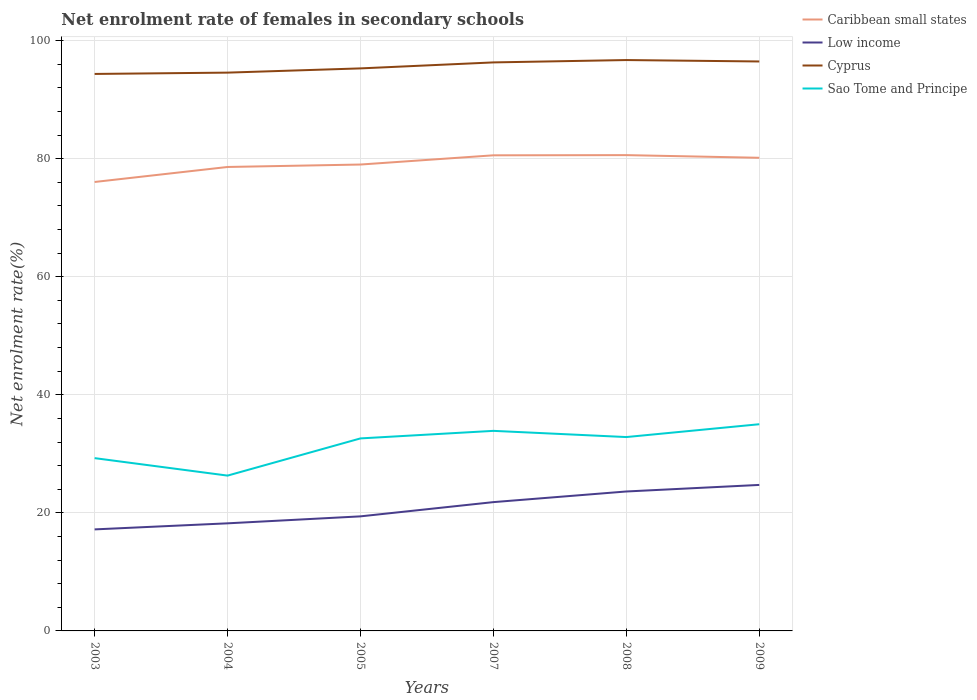How many different coloured lines are there?
Make the answer very short. 4. Across all years, what is the maximum net enrolment rate of females in secondary schools in Sao Tome and Principe?
Offer a very short reply. 26.31. In which year was the net enrolment rate of females in secondary schools in Low income maximum?
Your answer should be very brief. 2003. What is the total net enrolment rate of females in secondary schools in Cyprus in the graph?
Ensure brevity in your answer.  -1.73. What is the difference between the highest and the second highest net enrolment rate of females in secondary schools in Sao Tome and Principe?
Ensure brevity in your answer.  8.7. Is the net enrolment rate of females in secondary schools in Sao Tome and Principe strictly greater than the net enrolment rate of females in secondary schools in Low income over the years?
Give a very brief answer. No. How many lines are there?
Provide a succinct answer. 4. How many years are there in the graph?
Offer a terse response. 6. What is the difference between two consecutive major ticks on the Y-axis?
Give a very brief answer. 20. Does the graph contain any zero values?
Ensure brevity in your answer.  No. Does the graph contain grids?
Provide a short and direct response. Yes. Where does the legend appear in the graph?
Make the answer very short. Top right. What is the title of the graph?
Offer a very short reply. Net enrolment rate of females in secondary schools. What is the label or title of the X-axis?
Provide a succinct answer. Years. What is the label or title of the Y-axis?
Make the answer very short. Net enrolment rate(%). What is the Net enrolment rate(%) in Caribbean small states in 2003?
Ensure brevity in your answer.  76.05. What is the Net enrolment rate(%) in Low income in 2003?
Provide a succinct answer. 17.2. What is the Net enrolment rate(%) of Cyprus in 2003?
Offer a very short reply. 94.35. What is the Net enrolment rate(%) of Sao Tome and Principe in 2003?
Your answer should be compact. 29.27. What is the Net enrolment rate(%) of Caribbean small states in 2004?
Offer a very short reply. 78.59. What is the Net enrolment rate(%) of Low income in 2004?
Provide a succinct answer. 18.23. What is the Net enrolment rate(%) in Cyprus in 2004?
Your response must be concise. 94.57. What is the Net enrolment rate(%) of Sao Tome and Principe in 2004?
Your answer should be compact. 26.31. What is the Net enrolment rate(%) of Caribbean small states in 2005?
Provide a succinct answer. 79. What is the Net enrolment rate(%) in Low income in 2005?
Provide a succinct answer. 19.41. What is the Net enrolment rate(%) in Cyprus in 2005?
Keep it short and to the point. 95.29. What is the Net enrolment rate(%) of Sao Tome and Principe in 2005?
Your response must be concise. 32.61. What is the Net enrolment rate(%) of Caribbean small states in 2007?
Your answer should be very brief. 80.56. What is the Net enrolment rate(%) of Low income in 2007?
Provide a succinct answer. 21.82. What is the Net enrolment rate(%) of Cyprus in 2007?
Ensure brevity in your answer.  96.3. What is the Net enrolment rate(%) of Sao Tome and Principe in 2007?
Provide a succinct answer. 33.89. What is the Net enrolment rate(%) of Caribbean small states in 2008?
Provide a succinct answer. 80.6. What is the Net enrolment rate(%) of Low income in 2008?
Give a very brief answer. 23.62. What is the Net enrolment rate(%) in Cyprus in 2008?
Provide a short and direct response. 96.7. What is the Net enrolment rate(%) in Sao Tome and Principe in 2008?
Your answer should be compact. 32.84. What is the Net enrolment rate(%) in Caribbean small states in 2009?
Your response must be concise. 80.14. What is the Net enrolment rate(%) in Low income in 2009?
Your response must be concise. 24.73. What is the Net enrolment rate(%) of Cyprus in 2009?
Keep it short and to the point. 96.46. What is the Net enrolment rate(%) in Sao Tome and Principe in 2009?
Make the answer very short. 35.01. Across all years, what is the maximum Net enrolment rate(%) of Caribbean small states?
Your response must be concise. 80.6. Across all years, what is the maximum Net enrolment rate(%) in Low income?
Provide a succinct answer. 24.73. Across all years, what is the maximum Net enrolment rate(%) of Cyprus?
Keep it short and to the point. 96.7. Across all years, what is the maximum Net enrolment rate(%) of Sao Tome and Principe?
Provide a short and direct response. 35.01. Across all years, what is the minimum Net enrolment rate(%) of Caribbean small states?
Offer a terse response. 76.05. Across all years, what is the minimum Net enrolment rate(%) of Low income?
Your answer should be very brief. 17.2. Across all years, what is the minimum Net enrolment rate(%) of Cyprus?
Ensure brevity in your answer.  94.35. Across all years, what is the minimum Net enrolment rate(%) in Sao Tome and Principe?
Your response must be concise. 26.31. What is the total Net enrolment rate(%) of Caribbean small states in the graph?
Make the answer very short. 474.94. What is the total Net enrolment rate(%) of Low income in the graph?
Keep it short and to the point. 125. What is the total Net enrolment rate(%) in Cyprus in the graph?
Your answer should be compact. 573.66. What is the total Net enrolment rate(%) in Sao Tome and Principe in the graph?
Provide a succinct answer. 189.93. What is the difference between the Net enrolment rate(%) of Caribbean small states in 2003 and that in 2004?
Ensure brevity in your answer.  -2.54. What is the difference between the Net enrolment rate(%) in Low income in 2003 and that in 2004?
Keep it short and to the point. -1.03. What is the difference between the Net enrolment rate(%) in Cyprus in 2003 and that in 2004?
Keep it short and to the point. -0.22. What is the difference between the Net enrolment rate(%) in Sao Tome and Principe in 2003 and that in 2004?
Offer a very short reply. 2.96. What is the difference between the Net enrolment rate(%) in Caribbean small states in 2003 and that in 2005?
Keep it short and to the point. -2.96. What is the difference between the Net enrolment rate(%) in Low income in 2003 and that in 2005?
Provide a succinct answer. -2.21. What is the difference between the Net enrolment rate(%) in Cyprus in 2003 and that in 2005?
Offer a very short reply. -0.94. What is the difference between the Net enrolment rate(%) of Sao Tome and Principe in 2003 and that in 2005?
Give a very brief answer. -3.34. What is the difference between the Net enrolment rate(%) in Caribbean small states in 2003 and that in 2007?
Make the answer very short. -4.52. What is the difference between the Net enrolment rate(%) of Low income in 2003 and that in 2007?
Offer a terse response. -4.62. What is the difference between the Net enrolment rate(%) in Cyprus in 2003 and that in 2007?
Give a very brief answer. -1.95. What is the difference between the Net enrolment rate(%) of Sao Tome and Principe in 2003 and that in 2007?
Provide a succinct answer. -4.62. What is the difference between the Net enrolment rate(%) of Caribbean small states in 2003 and that in 2008?
Give a very brief answer. -4.55. What is the difference between the Net enrolment rate(%) in Low income in 2003 and that in 2008?
Offer a very short reply. -6.42. What is the difference between the Net enrolment rate(%) in Cyprus in 2003 and that in 2008?
Your answer should be very brief. -2.35. What is the difference between the Net enrolment rate(%) of Sao Tome and Principe in 2003 and that in 2008?
Keep it short and to the point. -3.57. What is the difference between the Net enrolment rate(%) of Caribbean small states in 2003 and that in 2009?
Ensure brevity in your answer.  -4.1. What is the difference between the Net enrolment rate(%) in Low income in 2003 and that in 2009?
Ensure brevity in your answer.  -7.53. What is the difference between the Net enrolment rate(%) of Cyprus in 2003 and that in 2009?
Your answer should be compact. -2.11. What is the difference between the Net enrolment rate(%) of Sao Tome and Principe in 2003 and that in 2009?
Make the answer very short. -5.74. What is the difference between the Net enrolment rate(%) of Caribbean small states in 2004 and that in 2005?
Provide a short and direct response. -0.41. What is the difference between the Net enrolment rate(%) in Low income in 2004 and that in 2005?
Keep it short and to the point. -1.18. What is the difference between the Net enrolment rate(%) in Cyprus in 2004 and that in 2005?
Give a very brief answer. -0.72. What is the difference between the Net enrolment rate(%) in Sao Tome and Principe in 2004 and that in 2005?
Make the answer very short. -6.3. What is the difference between the Net enrolment rate(%) of Caribbean small states in 2004 and that in 2007?
Offer a terse response. -1.98. What is the difference between the Net enrolment rate(%) in Low income in 2004 and that in 2007?
Ensure brevity in your answer.  -3.59. What is the difference between the Net enrolment rate(%) in Cyprus in 2004 and that in 2007?
Provide a succinct answer. -1.73. What is the difference between the Net enrolment rate(%) in Sao Tome and Principe in 2004 and that in 2007?
Provide a short and direct response. -7.58. What is the difference between the Net enrolment rate(%) in Caribbean small states in 2004 and that in 2008?
Your response must be concise. -2.01. What is the difference between the Net enrolment rate(%) of Low income in 2004 and that in 2008?
Offer a very short reply. -5.39. What is the difference between the Net enrolment rate(%) in Cyprus in 2004 and that in 2008?
Your answer should be very brief. -2.13. What is the difference between the Net enrolment rate(%) in Sao Tome and Principe in 2004 and that in 2008?
Your response must be concise. -6.53. What is the difference between the Net enrolment rate(%) in Caribbean small states in 2004 and that in 2009?
Make the answer very short. -1.56. What is the difference between the Net enrolment rate(%) in Low income in 2004 and that in 2009?
Provide a succinct answer. -6.51. What is the difference between the Net enrolment rate(%) in Cyprus in 2004 and that in 2009?
Offer a very short reply. -1.89. What is the difference between the Net enrolment rate(%) of Sao Tome and Principe in 2004 and that in 2009?
Your answer should be very brief. -8.7. What is the difference between the Net enrolment rate(%) in Caribbean small states in 2005 and that in 2007?
Offer a terse response. -1.56. What is the difference between the Net enrolment rate(%) in Low income in 2005 and that in 2007?
Make the answer very short. -2.41. What is the difference between the Net enrolment rate(%) of Cyprus in 2005 and that in 2007?
Ensure brevity in your answer.  -1.01. What is the difference between the Net enrolment rate(%) of Sao Tome and Principe in 2005 and that in 2007?
Make the answer very short. -1.28. What is the difference between the Net enrolment rate(%) of Caribbean small states in 2005 and that in 2008?
Keep it short and to the point. -1.59. What is the difference between the Net enrolment rate(%) in Low income in 2005 and that in 2008?
Make the answer very short. -4.21. What is the difference between the Net enrolment rate(%) in Cyprus in 2005 and that in 2008?
Offer a very short reply. -1.41. What is the difference between the Net enrolment rate(%) in Sao Tome and Principe in 2005 and that in 2008?
Your answer should be compact. -0.23. What is the difference between the Net enrolment rate(%) of Caribbean small states in 2005 and that in 2009?
Offer a terse response. -1.14. What is the difference between the Net enrolment rate(%) of Low income in 2005 and that in 2009?
Ensure brevity in your answer.  -5.32. What is the difference between the Net enrolment rate(%) of Cyprus in 2005 and that in 2009?
Give a very brief answer. -1.17. What is the difference between the Net enrolment rate(%) of Sao Tome and Principe in 2005 and that in 2009?
Offer a terse response. -2.4. What is the difference between the Net enrolment rate(%) in Caribbean small states in 2007 and that in 2008?
Provide a short and direct response. -0.03. What is the difference between the Net enrolment rate(%) in Low income in 2007 and that in 2008?
Ensure brevity in your answer.  -1.8. What is the difference between the Net enrolment rate(%) in Cyprus in 2007 and that in 2008?
Offer a terse response. -0.4. What is the difference between the Net enrolment rate(%) of Sao Tome and Principe in 2007 and that in 2008?
Provide a short and direct response. 1.05. What is the difference between the Net enrolment rate(%) of Caribbean small states in 2007 and that in 2009?
Give a very brief answer. 0.42. What is the difference between the Net enrolment rate(%) in Low income in 2007 and that in 2009?
Offer a very short reply. -2.91. What is the difference between the Net enrolment rate(%) in Cyprus in 2007 and that in 2009?
Provide a short and direct response. -0.16. What is the difference between the Net enrolment rate(%) of Sao Tome and Principe in 2007 and that in 2009?
Your response must be concise. -1.12. What is the difference between the Net enrolment rate(%) in Caribbean small states in 2008 and that in 2009?
Provide a succinct answer. 0.45. What is the difference between the Net enrolment rate(%) of Low income in 2008 and that in 2009?
Keep it short and to the point. -1.11. What is the difference between the Net enrolment rate(%) of Cyprus in 2008 and that in 2009?
Offer a very short reply. 0.24. What is the difference between the Net enrolment rate(%) of Sao Tome and Principe in 2008 and that in 2009?
Your response must be concise. -2.17. What is the difference between the Net enrolment rate(%) in Caribbean small states in 2003 and the Net enrolment rate(%) in Low income in 2004?
Keep it short and to the point. 57.82. What is the difference between the Net enrolment rate(%) in Caribbean small states in 2003 and the Net enrolment rate(%) in Cyprus in 2004?
Your response must be concise. -18.52. What is the difference between the Net enrolment rate(%) of Caribbean small states in 2003 and the Net enrolment rate(%) of Sao Tome and Principe in 2004?
Your answer should be compact. 49.74. What is the difference between the Net enrolment rate(%) in Low income in 2003 and the Net enrolment rate(%) in Cyprus in 2004?
Give a very brief answer. -77.37. What is the difference between the Net enrolment rate(%) of Low income in 2003 and the Net enrolment rate(%) of Sao Tome and Principe in 2004?
Offer a very short reply. -9.11. What is the difference between the Net enrolment rate(%) in Cyprus in 2003 and the Net enrolment rate(%) in Sao Tome and Principe in 2004?
Your answer should be compact. 68.04. What is the difference between the Net enrolment rate(%) of Caribbean small states in 2003 and the Net enrolment rate(%) of Low income in 2005?
Give a very brief answer. 56.64. What is the difference between the Net enrolment rate(%) in Caribbean small states in 2003 and the Net enrolment rate(%) in Cyprus in 2005?
Offer a terse response. -19.24. What is the difference between the Net enrolment rate(%) of Caribbean small states in 2003 and the Net enrolment rate(%) of Sao Tome and Principe in 2005?
Provide a short and direct response. 43.44. What is the difference between the Net enrolment rate(%) in Low income in 2003 and the Net enrolment rate(%) in Cyprus in 2005?
Your answer should be very brief. -78.09. What is the difference between the Net enrolment rate(%) in Low income in 2003 and the Net enrolment rate(%) in Sao Tome and Principe in 2005?
Ensure brevity in your answer.  -15.41. What is the difference between the Net enrolment rate(%) in Cyprus in 2003 and the Net enrolment rate(%) in Sao Tome and Principe in 2005?
Keep it short and to the point. 61.74. What is the difference between the Net enrolment rate(%) in Caribbean small states in 2003 and the Net enrolment rate(%) in Low income in 2007?
Keep it short and to the point. 54.23. What is the difference between the Net enrolment rate(%) of Caribbean small states in 2003 and the Net enrolment rate(%) of Cyprus in 2007?
Offer a terse response. -20.25. What is the difference between the Net enrolment rate(%) in Caribbean small states in 2003 and the Net enrolment rate(%) in Sao Tome and Principe in 2007?
Your response must be concise. 42.16. What is the difference between the Net enrolment rate(%) of Low income in 2003 and the Net enrolment rate(%) of Cyprus in 2007?
Your response must be concise. -79.1. What is the difference between the Net enrolment rate(%) in Low income in 2003 and the Net enrolment rate(%) in Sao Tome and Principe in 2007?
Your response must be concise. -16.69. What is the difference between the Net enrolment rate(%) in Cyprus in 2003 and the Net enrolment rate(%) in Sao Tome and Principe in 2007?
Ensure brevity in your answer.  60.46. What is the difference between the Net enrolment rate(%) of Caribbean small states in 2003 and the Net enrolment rate(%) of Low income in 2008?
Your answer should be very brief. 52.43. What is the difference between the Net enrolment rate(%) in Caribbean small states in 2003 and the Net enrolment rate(%) in Cyprus in 2008?
Your answer should be very brief. -20.65. What is the difference between the Net enrolment rate(%) in Caribbean small states in 2003 and the Net enrolment rate(%) in Sao Tome and Principe in 2008?
Ensure brevity in your answer.  43.21. What is the difference between the Net enrolment rate(%) of Low income in 2003 and the Net enrolment rate(%) of Cyprus in 2008?
Make the answer very short. -79.5. What is the difference between the Net enrolment rate(%) in Low income in 2003 and the Net enrolment rate(%) in Sao Tome and Principe in 2008?
Offer a terse response. -15.64. What is the difference between the Net enrolment rate(%) in Cyprus in 2003 and the Net enrolment rate(%) in Sao Tome and Principe in 2008?
Keep it short and to the point. 61.51. What is the difference between the Net enrolment rate(%) of Caribbean small states in 2003 and the Net enrolment rate(%) of Low income in 2009?
Your answer should be compact. 51.32. What is the difference between the Net enrolment rate(%) in Caribbean small states in 2003 and the Net enrolment rate(%) in Cyprus in 2009?
Ensure brevity in your answer.  -20.41. What is the difference between the Net enrolment rate(%) in Caribbean small states in 2003 and the Net enrolment rate(%) in Sao Tome and Principe in 2009?
Offer a very short reply. 41.04. What is the difference between the Net enrolment rate(%) in Low income in 2003 and the Net enrolment rate(%) in Cyprus in 2009?
Your response must be concise. -79.26. What is the difference between the Net enrolment rate(%) of Low income in 2003 and the Net enrolment rate(%) of Sao Tome and Principe in 2009?
Keep it short and to the point. -17.81. What is the difference between the Net enrolment rate(%) of Cyprus in 2003 and the Net enrolment rate(%) of Sao Tome and Principe in 2009?
Your response must be concise. 59.34. What is the difference between the Net enrolment rate(%) of Caribbean small states in 2004 and the Net enrolment rate(%) of Low income in 2005?
Give a very brief answer. 59.18. What is the difference between the Net enrolment rate(%) of Caribbean small states in 2004 and the Net enrolment rate(%) of Cyprus in 2005?
Offer a terse response. -16.7. What is the difference between the Net enrolment rate(%) of Caribbean small states in 2004 and the Net enrolment rate(%) of Sao Tome and Principe in 2005?
Keep it short and to the point. 45.98. What is the difference between the Net enrolment rate(%) in Low income in 2004 and the Net enrolment rate(%) in Cyprus in 2005?
Provide a succinct answer. -77.06. What is the difference between the Net enrolment rate(%) of Low income in 2004 and the Net enrolment rate(%) of Sao Tome and Principe in 2005?
Keep it short and to the point. -14.39. What is the difference between the Net enrolment rate(%) of Cyprus in 2004 and the Net enrolment rate(%) of Sao Tome and Principe in 2005?
Your answer should be very brief. 61.96. What is the difference between the Net enrolment rate(%) in Caribbean small states in 2004 and the Net enrolment rate(%) in Low income in 2007?
Your answer should be compact. 56.77. What is the difference between the Net enrolment rate(%) in Caribbean small states in 2004 and the Net enrolment rate(%) in Cyprus in 2007?
Give a very brief answer. -17.71. What is the difference between the Net enrolment rate(%) of Caribbean small states in 2004 and the Net enrolment rate(%) of Sao Tome and Principe in 2007?
Your answer should be compact. 44.7. What is the difference between the Net enrolment rate(%) of Low income in 2004 and the Net enrolment rate(%) of Cyprus in 2007?
Ensure brevity in your answer.  -78.08. What is the difference between the Net enrolment rate(%) in Low income in 2004 and the Net enrolment rate(%) in Sao Tome and Principe in 2007?
Offer a very short reply. -15.66. What is the difference between the Net enrolment rate(%) in Cyprus in 2004 and the Net enrolment rate(%) in Sao Tome and Principe in 2007?
Give a very brief answer. 60.68. What is the difference between the Net enrolment rate(%) in Caribbean small states in 2004 and the Net enrolment rate(%) in Low income in 2008?
Provide a succinct answer. 54.97. What is the difference between the Net enrolment rate(%) of Caribbean small states in 2004 and the Net enrolment rate(%) of Cyprus in 2008?
Ensure brevity in your answer.  -18.11. What is the difference between the Net enrolment rate(%) in Caribbean small states in 2004 and the Net enrolment rate(%) in Sao Tome and Principe in 2008?
Give a very brief answer. 45.75. What is the difference between the Net enrolment rate(%) in Low income in 2004 and the Net enrolment rate(%) in Cyprus in 2008?
Your answer should be very brief. -78.48. What is the difference between the Net enrolment rate(%) of Low income in 2004 and the Net enrolment rate(%) of Sao Tome and Principe in 2008?
Provide a succinct answer. -14.61. What is the difference between the Net enrolment rate(%) of Cyprus in 2004 and the Net enrolment rate(%) of Sao Tome and Principe in 2008?
Give a very brief answer. 61.73. What is the difference between the Net enrolment rate(%) in Caribbean small states in 2004 and the Net enrolment rate(%) in Low income in 2009?
Keep it short and to the point. 53.86. What is the difference between the Net enrolment rate(%) in Caribbean small states in 2004 and the Net enrolment rate(%) in Cyprus in 2009?
Your response must be concise. -17.87. What is the difference between the Net enrolment rate(%) of Caribbean small states in 2004 and the Net enrolment rate(%) of Sao Tome and Principe in 2009?
Offer a terse response. 43.58. What is the difference between the Net enrolment rate(%) in Low income in 2004 and the Net enrolment rate(%) in Cyprus in 2009?
Provide a succinct answer. -78.23. What is the difference between the Net enrolment rate(%) of Low income in 2004 and the Net enrolment rate(%) of Sao Tome and Principe in 2009?
Your answer should be very brief. -16.79. What is the difference between the Net enrolment rate(%) in Cyprus in 2004 and the Net enrolment rate(%) in Sao Tome and Principe in 2009?
Offer a very short reply. 59.56. What is the difference between the Net enrolment rate(%) in Caribbean small states in 2005 and the Net enrolment rate(%) in Low income in 2007?
Your answer should be compact. 57.18. What is the difference between the Net enrolment rate(%) in Caribbean small states in 2005 and the Net enrolment rate(%) in Cyprus in 2007?
Ensure brevity in your answer.  -17.3. What is the difference between the Net enrolment rate(%) of Caribbean small states in 2005 and the Net enrolment rate(%) of Sao Tome and Principe in 2007?
Your answer should be very brief. 45.11. What is the difference between the Net enrolment rate(%) in Low income in 2005 and the Net enrolment rate(%) in Cyprus in 2007?
Provide a short and direct response. -76.89. What is the difference between the Net enrolment rate(%) in Low income in 2005 and the Net enrolment rate(%) in Sao Tome and Principe in 2007?
Make the answer very short. -14.48. What is the difference between the Net enrolment rate(%) in Cyprus in 2005 and the Net enrolment rate(%) in Sao Tome and Principe in 2007?
Your answer should be compact. 61.4. What is the difference between the Net enrolment rate(%) in Caribbean small states in 2005 and the Net enrolment rate(%) in Low income in 2008?
Your answer should be compact. 55.38. What is the difference between the Net enrolment rate(%) of Caribbean small states in 2005 and the Net enrolment rate(%) of Cyprus in 2008?
Your answer should be very brief. -17.7. What is the difference between the Net enrolment rate(%) of Caribbean small states in 2005 and the Net enrolment rate(%) of Sao Tome and Principe in 2008?
Give a very brief answer. 46.16. What is the difference between the Net enrolment rate(%) of Low income in 2005 and the Net enrolment rate(%) of Cyprus in 2008?
Provide a succinct answer. -77.29. What is the difference between the Net enrolment rate(%) in Low income in 2005 and the Net enrolment rate(%) in Sao Tome and Principe in 2008?
Offer a very short reply. -13.43. What is the difference between the Net enrolment rate(%) in Cyprus in 2005 and the Net enrolment rate(%) in Sao Tome and Principe in 2008?
Give a very brief answer. 62.45. What is the difference between the Net enrolment rate(%) of Caribbean small states in 2005 and the Net enrolment rate(%) of Low income in 2009?
Make the answer very short. 54.27. What is the difference between the Net enrolment rate(%) in Caribbean small states in 2005 and the Net enrolment rate(%) in Cyprus in 2009?
Your answer should be very brief. -17.46. What is the difference between the Net enrolment rate(%) in Caribbean small states in 2005 and the Net enrolment rate(%) in Sao Tome and Principe in 2009?
Ensure brevity in your answer.  43.99. What is the difference between the Net enrolment rate(%) in Low income in 2005 and the Net enrolment rate(%) in Cyprus in 2009?
Your response must be concise. -77.05. What is the difference between the Net enrolment rate(%) of Low income in 2005 and the Net enrolment rate(%) of Sao Tome and Principe in 2009?
Give a very brief answer. -15.6. What is the difference between the Net enrolment rate(%) of Cyprus in 2005 and the Net enrolment rate(%) of Sao Tome and Principe in 2009?
Your response must be concise. 60.28. What is the difference between the Net enrolment rate(%) in Caribbean small states in 2007 and the Net enrolment rate(%) in Low income in 2008?
Offer a very short reply. 56.94. What is the difference between the Net enrolment rate(%) of Caribbean small states in 2007 and the Net enrolment rate(%) of Cyprus in 2008?
Ensure brevity in your answer.  -16.14. What is the difference between the Net enrolment rate(%) of Caribbean small states in 2007 and the Net enrolment rate(%) of Sao Tome and Principe in 2008?
Your response must be concise. 47.73. What is the difference between the Net enrolment rate(%) in Low income in 2007 and the Net enrolment rate(%) in Cyprus in 2008?
Make the answer very short. -74.88. What is the difference between the Net enrolment rate(%) in Low income in 2007 and the Net enrolment rate(%) in Sao Tome and Principe in 2008?
Ensure brevity in your answer.  -11.02. What is the difference between the Net enrolment rate(%) in Cyprus in 2007 and the Net enrolment rate(%) in Sao Tome and Principe in 2008?
Provide a succinct answer. 63.46. What is the difference between the Net enrolment rate(%) of Caribbean small states in 2007 and the Net enrolment rate(%) of Low income in 2009?
Your answer should be compact. 55.83. What is the difference between the Net enrolment rate(%) of Caribbean small states in 2007 and the Net enrolment rate(%) of Cyprus in 2009?
Provide a short and direct response. -15.9. What is the difference between the Net enrolment rate(%) in Caribbean small states in 2007 and the Net enrolment rate(%) in Sao Tome and Principe in 2009?
Offer a very short reply. 45.55. What is the difference between the Net enrolment rate(%) in Low income in 2007 and the Net enrolment rate(%) in Cyprus in 2009?
Give a very brief answer. -74.64. What is the difference between the Net enrolment rate(%) in Low income in 2007 and the Net enrolment rate(%) in Sao Tome and Principe in 2009?
Provide a short and direct response. -13.19. What is the difference between the Net enrolment rate(%) in Cyprus in 2007 and the Net enrolment rate(%) in Sao Tome and Principe in 2009?
Your answer should be very brief. 61.29. What is the difference between the Net enrolment rate(%) of Caribbean small states in 2008 and the Net enrolment rate(%) of Low income in 2009?
Offer a terse response. 55.86. What is the difference between the Net enrolment rate(%) of Caribbean small states in 2008 and the Net enrolment rate(%) of Cyprus in 2009?
Provide a succinct answer. -15.86. What is the difference between the Net enrolment rate(%) in Caribbean small states in 2008 and the Net enrolment rate(%) in Sao Tome and Principe in 2009?
Make the answer very short. 45.58. What is the difference between the Net enrolment rate(%) of Low income in 2008 and the Net enrolment rate(%) of Cyprus in 2009?
Provide a succinct answer. -72.84. What is the difference between the Net enrolment rate(%) in Low income in 2008 and the Net enrolment rate(%) in Sao Tome and Principe in 2009?
Provide a short and direct response. -11.39. What is the difference between the Net enrolment rate(%) in Cyprus in 2008 and the Net enrolment rate(%) in Sao Tome and Principe in 2009?
Provide a short and direct response. 61.69. What is the average Net enrolment rate(%) in Caribbean small states per year?
Make the answer very short. 79.16. What is the average Net enrolment rate(%) in Low income per year?
Keep it short and to the point. 20.83. What is the average Net enrolment rate(%) in Cyprus per year?
Give a very brief answer. 95.61. What is the average Net enrolment rate(%) of Sao Tome and Principe per year?
Your answer should be compact. 31.65. In the year 2003, what is the difference between the Net enrolment rate(%) of Caribbean small states and Net enrolment rate(%) of Low income?
Offer a very short reply. 58.85. In the year 2003, what is the difference between the Net enrolment rate(%) in Caribbean small states and Net enrolment rate(%) in Cyprus?
Provide a short and direct response. -18.3. In the year 2003, what is the difference between the Net enrolment rate(%) of Caribbean small states and Net enrolment rate(%) of Sao Tome and Principe?
Give a very brief answer. 46.78. In the year 2003, what is the difference between the Net enrolment rate(%) of Low income and Net enrolment rate(%) of Cyprus?
Keep it short and to the point. -77.15. In the year 2003, what is the difference between the Net enrolment rate(%) of Low income and Net enrolment rate(%) of Sao Tome and Principe?
Your answer should be compact. -12.07. In the year 2003, what is the difference between the Net enrolment rate(%) of Cyprus and Net enrolment rate(%) of Sao Tome and Principe?
Make the answer very short. 65.08. In the year 2004, what is the difference between the Net enrolment rate(%) of Caribbean small states and Net enrolment rate(%) of Low income?
Give a very brief answer. 60.36. In the year 2004, what is the difference between the Net enrolment rate(%) of Caribbean small states and Net enrolment rate(%) of Cyprus?
Provide a succinct answer. -15.98. In the year 2004, what is the difference between the Net enrolment rate(%) in Caribbean small states and Net enrolment rate(%) in Sao Tome and Principe?
Offer a very short reply. 52.28. In the year 2004, what is the difference between the Net enrolment rate(%) of Low income and Net enrolment rate(%) of Cyprus?
Your answer should be compact. -76.34. In the year 2004, what is the difference between the Net enrolment rate(%) of Low income and Net enrolment rate(%) of Sao Tome and Principe?
Offer a very short reply. -8.08. In the year 2004, what is the difference between the Net enrolment rate(%) of Cyprus and Net enrolment rate(%) of Sao Tome and Principe?
Offer a very short reply. 68.26. In the year 2005, what is the difference between the Net enrolment rate(%) in Caribbean small states and Net enrolment rate(%) in Low income?
Ensure brevity in your answer.  59.6. In the year 2005, what is the difference between the Net enrolment rate(%) in Caribbean small states and Net enrolment rate(%) in Cyprus?
Keep it short and to the point. -16.29. In the year 2005, what is the difference between the Net enrolment rate(%) of Caribbean small states and Net enrolment rate(%) of Sao Tome and Principe?
Give a very brief answer. 46.39. In the year 2005, what is the difference between the Net enrolment rate(%) in Low income and Net enrolment rate(%) in Cyprus?
Give a very brief answer. -75.88. In the year 2005, what is the difference between the Net enrolment rate(%) of Low income and Net enrolment rate(%) of Sao Tome and Principe?
Provide a succinct answer. -13.2. In the year 2005, what is the difference between the Net enrolment rate(%) of Cyprus and Net enrolment rate(%) of Sao Tome and Principe?
Your answer should be very brief. 62.68. In the year 2007, what is the difference between the Net enrolment rate(%) in Caribbean small states and Net enrolment rate(%) in Low income?
Make the answer very short. 58.75. In the year 2007, what is the difference between the Net enrolment rate(%) in Caribbean small states and Net enrolment rate(%) in Cyprus?
Offer a terse response. -15.74. In the year 2007, what is the difference between the Net enrolment rate(%) in Caribbean small states and Net enrolment rate(%) in Sao Tome and Principe?
Your answer should be very brief. 46.68. In the year 2007, what is the difference between the Net enrolment rate(%) of Low income and Net enrolment rate(%) of Cyprus?
Offer a very short reply. -74.48. In the year 2007, what is the difference between the Net enrolment rate(%) in Low income and Net enrolment rate(%) in Sao Tome and Principe?
Your response must be concise. -12.07. In the year 2007, what is the difference between the Net enrolment rate(%) in Cyprus and Net enrolment rate(%) in Sao Tome and Principe?
Give a very brief answer. 62.41. In the year 2008, what is the difference between the Net enrolment rate(%) in Caribbean small states and Net enrolment rate(%) in Low income?
Your answer should be compact. 56.98. In the year 2008, what is the difference between the Net enrolment rate(%) in Caribbean small states and Net enrolment rate(%) in Cyprus?
Provide a succinct answer. -16.11. In the year 2008, what is the difference between the Net enrolment rate(%) of Caribbean small states and Net enrolment rate(%) of Sao Tome and Principe?
Give a very brief answer. 47.76. In the year 2008, what is the difference between the Net enrolment rate(%) of Low income and Net enrolment rate(%) of Cyprus?
Offer a very short reply. -73.08. In the year 2008, what is the difference between the Net enrolment rate(%) of Low income and Net enrolment rate(%) of Sao Tome and Principe?
Provide a succinct answer. -9.22. In the year 2008, what is the difference between the Net enrolment rate(%) in Cyprus and Net enrolment rate(%) in Sao Tome and Principe?
Make the answer very short. 63.86. In the year 2009, what is the difference between the Net enrolment rate(%) of Caribbean small states and Net enrolment rate(%) of Low income?
Keep it short and to the point. 55.41. In the year 2009, what is the difference between the Net enrolment rate(%) of Caribbean small states and Net enrolment rate(%) of Cyprus?
Keep it short and to the point. -16.32. In the year 2009, what is the difference between the Net enrolment rate(%) of Caribbean small states and Net enrolment rate(%) of Sao Tome and Principe?
Offer a terse response. 45.13. In the year 2009, what is the difference between the Net enrolment rate(%) in Low income and Net enrolment rate(%) in Cyprus?
Offer a very short reply. -71.73. In the year 2009, what is the difference between the Net enrolment rate(%) of Low income and Net enrolment rate(%) of Sao Tome and Principe?
Offer a very short reply. -10.28. In the year 2009, what is the difference between the Net enrolment rate(%) of Cyprus and Net enrolment rate(%) of Sao Tome and Principe?
Your response must be concise. 61.45. What is the ratio of the Net enrolment rate(%) in Low income in 2003 to that in 2004?
Your answer should be very brief. 0.94. What is the ratio of the Net enrolment rate(%) in Sao Tome and Principe in 2003 to that in 2004?
Keep it short and to the point. 1.11. What is the ratio of the Net enrolment rate(%) in Caribbean small states in 2003 to that in 2005?
Your answer should be compact. 0.96. What is the ratio of the Net enrolment rate(%) in Low income in 2003 to that in 2005?
Give a very brief answer. 0.89. What is the ratio of the Net enrolment rate(%) in Cyprus in 2003 to that in 2005?
Your answer should be very brief. 0.99. What is the ratio of the Net enrolment rate(%) of Sao Tome and Principe in 2003 to that in 2005?
Your answer should be compact. 0.9. What is the ratio of the Net enrolment rate(%) in Caribbean small states in 2003 to that in 2007?
Make the answer very short. 0.94. What is the ratio of the Net enrolment rate(%) of Low income in 2003 to that in 2007?
Your answer should be very brief. 0.79. What is the ratio of the Net enrolment rate(%) of Cyprus in 2003 to that in 2007?
Provide a short and direct response. 0.98. What is the ratio of the Net enrolment rate(%) in Sao Tome and Principe in 2003 to that in 2007?
Your answer should be compact. 0.86. What is the ratio of the Net enrolment rate(%) in Caribbean small states in 2003 to that in 2008?
Keep it short and to the point. 0.94. What is the ratio of the Net enrolment rate(%) of Low income in 2003 to that in 2008?
Your answer should be compact. 0.73. What is the ratio of the Net enrolment rate(%) in Cyprus in 2003 to that in 2008?
Ensure brevity in your answer.  0.98. What is the ratio of the Net enrolment rate(%) in Sao Tome and Principe in 2003 to that in 2008?
Your answer should be very brief. 0.89. What is the ratio of the Net enrolment rate(%) of Caribbean small states in 2003 to that in 2009?
Your answer should be very brief. 0.95. What is the ratio of the Net enrolment rate(%) in Low income in 2003 to that in 2009?
Your answer should be very brief. 0.7. What is the ratio of the Net enrolment rate(%) in Cyprus in 2003 to that in 2009?
Make the answer very short. 0.98. What is the ratio of the Net enrolment rate(%) in Sao Tome and Principe in 2003 to that in 2009?
Ensure brevity in your answer.  0.84. What is the ratio of the Net enrolment rate(%) of Low income in 2004 to that in 2005?
Provide a short and direct response. 0.94. What is the ratio of the Net enrolment rate(%) in Sao Tome and Principe in 2004 to that in 2005?
Give a very brief answer. 0.81. What is the ratio of the Net enrolment rate(%) in Caribbean small states in 2004 to that in 2007?
Ensure brevity in your answer.  0.98. What is the ratio of the Net enrolment rate(%) in Low income in 2004 to that in 2007?
Ensure brevity in your answer.  0.84. What is the ratio of the Net enrolment rate(%) in Sao Tome and Principe in 2004 to that in 2007?
Provide a succinct answer. 0.78. What is the ratio of the Net enrolment rate(%) in Caribbean small states in 2004 to that in 2008?
Your answer should be very brief. 0.98. What is the ratio of the Net enrolment rate(%) in Low income in 2004 to that in 2008?
Ensure brevity in your answer.  0.77. What is the ratio of the Net enrolment rate(%) in Sao Tome and Principe in 2004 to that in 2008?
Ensure brevity in your answer.  0.8. What is the ratio of the Net enrolment rate(%) in Caribbean small states in 2004 to that in 2009?
Offer a very short reply. 0.98. What is the ratio of the Net enrolment rate(%) of Low income in 2004 to that in 2009?
Provide a succinct answer. 0.74. What is the ratio of the Net enrolment rate(%) of Cyprus in 2004 to that in 2009?
Keep it short and to the point. 0.98. What is the ratio of the Net enrolment rate(%) in Sao Tome and Principe in 2004 to that in 2009?
Give a very brief answer. 0.75. What is the ratio of the Net enrolment rate(%) in Caribbean small states in 2005 to that in 2007?
Give a very brief answer. 0.98. What is the ratio of the Net enrolment rate(%) of Low income in 2005 to that in 2007?
Offer a very short reply. 0.89. What is the ratio of the Net enrolment rate(%) in Cyprus in 2005 to that in 2007?
Your answer should be very brief. 0.99. What is the ratio of the Net enrolment rate(%) of Sao Tome and Principe in 2005 to that in 2007?
Ensure brevity in your answer.  0.96. What is the ratio of the Net enrolment rate(%) in Caribbean small states in 2005 to that in 2008?
Provide a succinct answer. 0.98. What is the ratio of the Net enrolment rate(%) of Low income in 2005 to that in 2008?
Provide a short and direct response. 0.82. What is the ratio of the Net enrolment rate(%) of Cyprus in 2005 to that in 2008?
Your answer should be compact. 0.99. What is the ratio of the Net enrolment rate(%) in Caribbean small states in 2005 to that in 2009?
Your response must be concise. 0.99. What is the ratio of the Net enrolment rate(%) of Low income in 2005 to that in 2009?
Make the answer very short. 0.78. What is the ratio of the Net enrolment rate(%) in Cyprus in 2005 to that in 2009?
Offer a very short reply. 0.99. What is the ratio of the Net enrolment rate(%) of Sao Tome and Principe in 2005 to that in 2009?
Offer a terse response. 0.93. What is the ratio of the Net enrolment rate(%) of Caribbean small states in 2007 to that in 2008?
Offer a terse response. 1. What is the ratio of the Net enrolment rate(%) of Low income in 2007 to that in 2008?
Your response must be concise. 0.92. What is the ratio of the Net enrolment rate(%) of Sao Tome and Principe in 2007 to that in 2008?
Your response must be concise. 1.03. What is the ratio of the Net enrolment rate(%) in Low income in 2007 to that in 2009?
Keep it short and to the point. 0.88. What is the ratio of the Net enrolment rate(%) in Cyprus in 2007 to that in 2009?
Your answer should be compact. 1. What is the ratio of the Net enrolment rate(%) of Sao Tome and Principe in 2007 to that in 2009?
Ensure brevity in your answer.  0.97. What is the ratio of the Net enrolment rate(%) in Caribbean small states in 2008 to that in 2009?
Offer a terse response. 1.01. What is the ratio of the Net enrolment rate(%) in Low income in 2008 to that in 2009?
Keep it short and to the point. 0.96. What is the ratio of the Net enrolment rate(%) of Cyprus in 2008 to that in 2009?
Offer a terse response. 1. What is the ratio of the Net enrolment rate(%) in Sao Tome and Principe in 2008 to that in 2009?
Provide a short and direct response. 0.94. What is the difference between the highest and the second highest Net enrolment rate(%) of Caribbean small states?
Offer a terse response. 0.03. What is the difference between the highest and the second highest Net enrolment rate(%) in Low income?
Provide a short and direct response. 1.11. What is the difference between the highest and the second highest Net enrolment rate(%) of Cyprus?
Keep it short and to the point. 0.24. What is the difference between the highest and the second highest Net enrolment rate(%) of Sao Tome and Principe?
Ensure brevity in your answer.  1.12. What is the difference between the highest and the lowest Net enrolment rate(%) in Caribbean small states?
Offer a terse response. 4.55. What is the difference between the highest and the lowest Net enrolment rate(%) of Low income?
Provide a succinct answer. 7.53. What is the difference between the highest and the lowest Net enrolment rate(%) in Cyprus?
Your answer should be compact. 2.35. What is the difference between the highest and the lowest Net enrolment rate(%) of Sao Tome and Principe?
Make the answer very short. 8.7. 